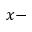<formula> <loc_0><loc_0><loc_500><loc_500>x -</formula> 